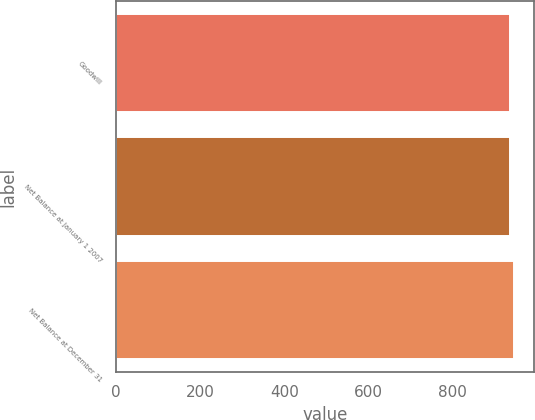Convert chart. <chart><loc_0><loc_0><loc_500><loc_500><bar_chart><fcel>Goodwill<fcel>Net Balance at January 1 2007<fcel>Net Balance at December 31<nl><fcel>935<fcel>936.1<fcel>946<nl></chart> 